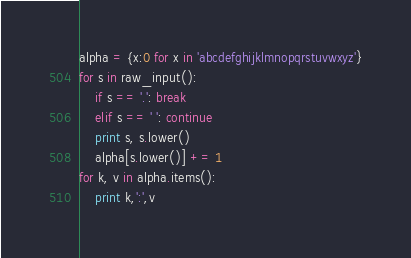<code> <loc_0><loc_0><loc_500><loc_500><_Python_>alpha = {x:0 for x in 'abcdefghijklmnopqrstuvwxyz'}
for s in raw_input():
    if s == '.': break
    elif s == ' ': continue
    print s, s.lower()
    alpha[s.lower()] += 1
for k, v in alpha.items():
    print k,':',v</code> 